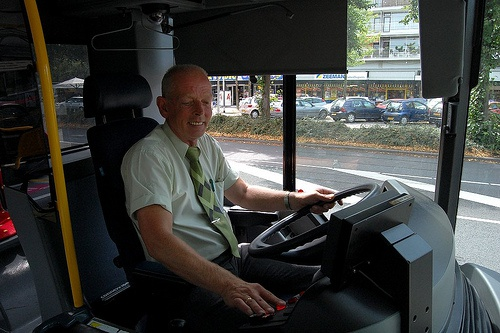Describe the objects in this image and their specific colors. I can see people in black, gray, maroon, and darkgray tones, chair in black and gray tones, car in black, gray, white, and darkgray tones, and tie in black, gray, and darkgreen tones in this image. 